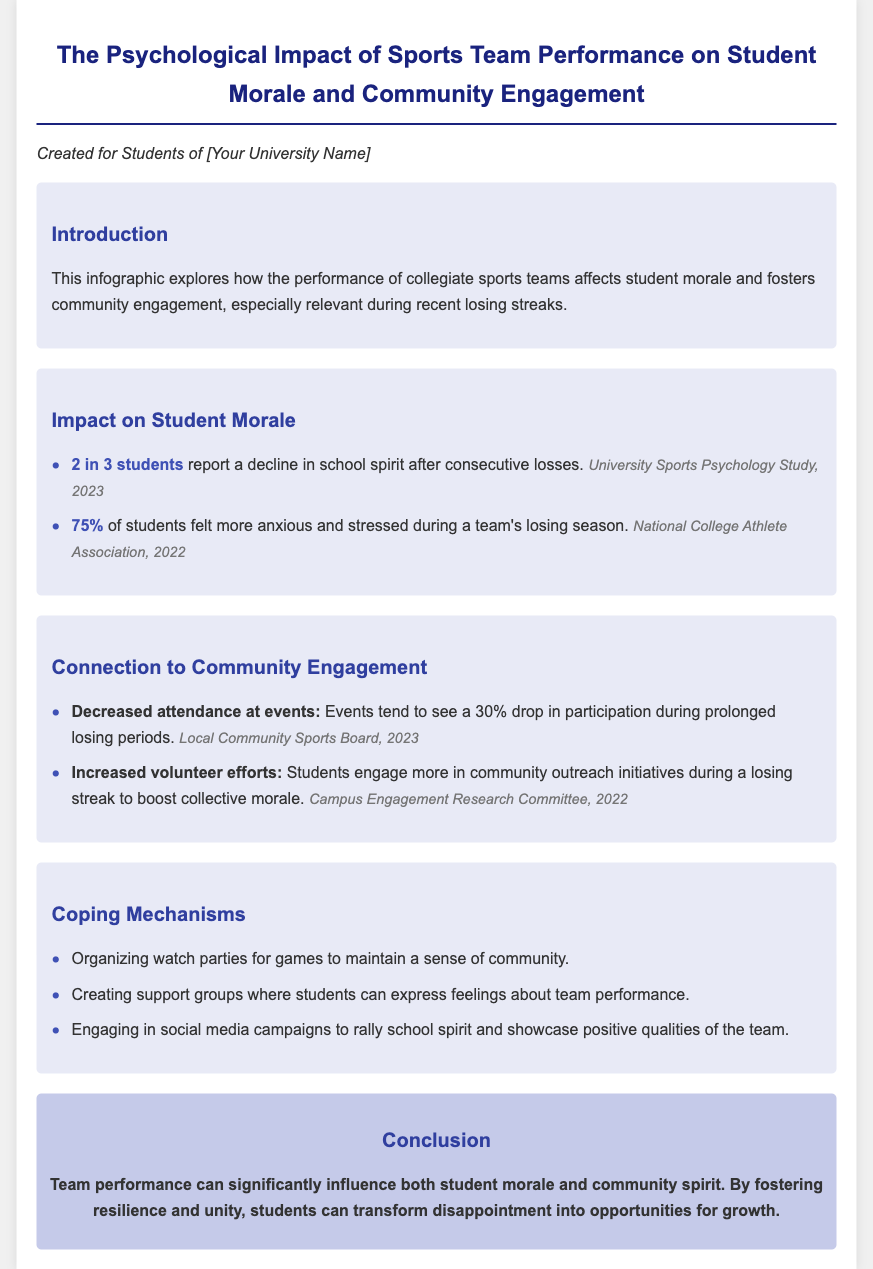What is the title of the document? The title is presented at the beginning of the document and is "The Psychological Impact of Sports Team Performance on Student Morale and Community Engagement."
Answer: The Psychological Impact of Sports Team Performance on Student Morale and Community Engagement What percentage of students report a decline in school spirit after consecutive losses? The document states that 2 in 3 students report a decline in school spirit after consecutive losses.
Answer: 2 in 3 What was the percentage of students who felt more anxious during a losing season? The document mentions that 75% of students felt more anxious and stressed during a team's losing season.
Answer: 75% What drop in event participation is mentioned during prolonged losing periods? The document specifies that events tend to see a 30% drop in participation during prolonged losing periods.
Answer: 30% What are students engaging more in during a losing streak to boost morale? The document indicates that students increase their involvement in community outreach initiatives during a losing streak to boost collective morale.
Answer: Community outreach initiatives What is one coping mechanism mentioned for maintaining community? The document lists several coping mechanisms, one of which is "Organizing watch parties for games to maintain a sense of community."
Answer: Organizing watch parties What is the overall conclusion about team performance's influence? The final section summarizes the conclusion that team performance significantly influences both student morale and community spirit.
Answer: Significantly influences both student morale and community spirit 